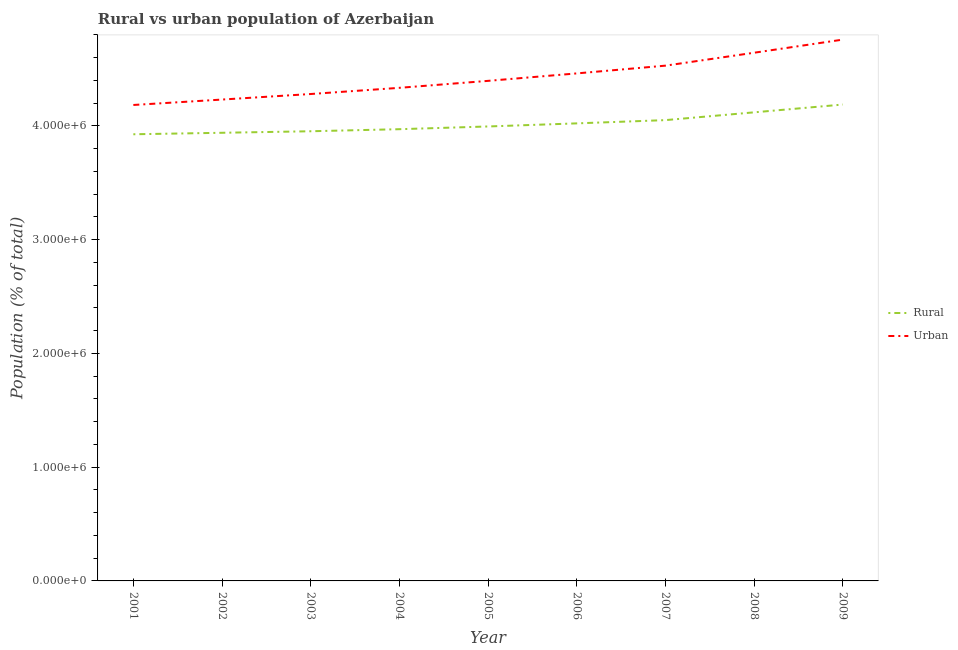How many different coloured lines are there?
Your answer should be compact. 2. What is the rural population density in 2007?
Give a very brief answer. 4.05e+06. Across all years, what is the maximum rural population density?
Your answer should be very brief. 4.19e+06. Across all years, what is the minimum urban population density?
Provide a succinct answer. 4.18e+06. What is the total urban population density in the graph?
Your response must be concise. 3.98e+07. What is the difference between the urban population density in 2002 and that in 2009?
Your answer should be very brief. -5.27e+05. What is the difference between the urban population density in 2003 and the rural population density in 2007?
Provide a succinct answer. 2.30e+05. What is the average rural population density per year?
Give a very brief answer. 4.02e+06. In the year 2004, what is the difference between the urban population density and rural population density?
Keep it short and to the point. 3.64e+05. In how many years, is the rural population density greater than 4400000 %?
Your answer should be very brief. 0. What is the ratio of the urban population density in 2008 to that in 2009?
Ensure brevity in your answer.  0.98. Is the difference between the rural population density in 2004 and 2009 greater than the difference between the urban population density in 2004 and 2009?
Provide a succinct answer. Yes. What is the difference between the highest and the second highest urban population density?
Make the answer very short. 1.15e+05. What is the difference between the highest and the lowest rural population density?
Keep it short and to the point. 2.61e+05. In how many years, is the rural population density greater than the average rural population density taken over all years?
Give a very brief answer. 4. Is the sum of the rural population density in 2001 and 2006 greater than the maximum urban population density across all years?
Your answer should be very brief. Yes. Is the urban population density strictly less than the rural population density over the years?
Your answer should be very brief. No. How many lines are there?
Offer a terse response. 2. How many years are there in the graph?
Provide a short and direct response. 9. Are the values on the major ticks of Y-axis written in scientific E-notation?
Offer a very short reply. Yes. Does the graph contain grids?
Your answer should be compact. No. How many legend labels are there?
Make the answer very short. 2. How are the legend labels stacked?
Ensure brevity in your answer.  Vertical. What is the title of the graph?
Provide a short and direct response. Rural vs urban population of Azerbaijan. What is the label or title of the X-axis?
Your answer should be very brief. Year. What is the label or title of the Y-axis?
Offer a very short reply. Population (% of total). What is the Population (% of total) in Rural in 2001?
Provide a succinct answer. 3.93e+06. What is the Population (% of total) of Urban in 2001?
Offer a terse response. 4.18e+06. What is the Population (% of total) of Rural in 2002?
Provide a succinct answer. 3.94e+06. What is the Population (% of total) in Urban in 2002?
Ensure brevity in your answer.  4.23e+06. What is the Population (% of total) of Rural in 2003?
Your answer should be compact. 3.95e+06. What is the Population (% of total) in Urban in 2003?
Make the answer very short. 4.28e+06. What is the Population (% of total) in Rural in 2004?
Your answer should be very brief. 3.97e+06. What is the Population (% of total) of Urban in 2004?
Give a very brief answer. 4.34e+06. What is the Population (% of total) in Rural in 2005?
Provide a succinct answer. 4.00e+06. What is the Population (% of total) of Urban in 2005?
Offer a very short reply. 4.40e+06. What is the Population (% of total) of Rural in 2006?
Ensure brevity in your answer.  4.02e+06. What is the Population (% of total) of Urban in 2006?
Your answer should be compact. 4.46e+06. What is the Population (% of total) in Rural in 2007?
Offer a terse response. 4.05e+06. What is the Population (% of total) of Urban in 2007?
Offer a terse response. 4.53e+06. What is the Population (% of total) in Rural in 2008?
Give a very brief answer. 4.12e+06. What is the Population (% of total) in Urban in 2008?
Ensure brevity in your answer.  4.64e+06. What is the Population (% of total) of Rural in 2009?
Your answer should be very brief. 4.19e+06. What is the Population (% of total) in Urban in 2009?
Give a very brief answer. 4.76e+06. Across all years, what is the maximum Population (% of total) of Rural?
Your answer should be compact. 4.19e+06. Across all years, what is the maximum Population (% of total) of Urban?
Provide a short and direct response. 4.76e+06. Across all years, what is the minimum Population (% of total) of Rural?
Make the answer very short. 3.93e+06. Across all years, what is the minimum Population (% of total) in Urban?
Offer a very short reply. 4.18e+06. What is the total Population (% of total) of Rural in the graph?
Provide a succinct answer. 3.62e+07. What is the total Population (% of total) of Urban in the graph?
Your answer should be compact. 3.98e+07. What is the difference between the Population (% of total) of Rural in 2001 and that in 2002?
Your answer should be very brief. -1.31e+04. What is the difference between the Population (% of total) in Urban in 2001 and that in 2002?
Your response must be concise. -4.77e+04. What is the difference between the Population (% of total) in Rural in 2001 and that in 2003?
Provide a succinct answer. -2.65e+04. What is the difference between the Population (% of total) of Urban in 2001 and that in 2003?
Your answer should be very brief. -9.64e+04. What is the difference between the Population (% of total) of Rural in 2001 and that in 2004?
Ensure brevity in your answer.  -4.45e+04. What is the difference between the Population (% of total) in Urban in 2001 and that in 2004?
Make the answer very short. -1.51e+05. What is the difference between the Population (% of total) of Rural in 2001 and that in 2005?
Ensure brevity in your answer.  -6.86e+04. What is the difference between the Population (% of total) of Urban in 2001 and that in 2005?
Your response must be concise. -2.12e+05. What is the difference between the Population (% of total) of Rural in 2001 and that in 2006?
Ensure brevity in your answer.  -9.57e+04. What is the difference between the Population (% of total) in Urban in 2001 and that in 2006?
Provide a succinct answer. -2.78e+05. What is the difference between the Population (% of total) in Rural in 2001 and that in 2007?
Your answer should be very brief. -1.24e+05. What is the difference between the Population (% of total) of Urban in 2001 and that in 2007?
Give a very brief answer. -3.46e+05. What is the difference between the Population (% of total) in Rural in 2001 and that in 2008?
Keep it short and to the point. -1.93e+05. What is the difference between the Population (% of total) of Urban in 2001 and that in 2008?
Offer a very short reply. -4.59e+05. What is the difference between the Population (% of total) of Rural in 2001 and that in 2009?
Provide a succinct answer. -2.61e+05. What is the difference between the Population (% of total) in Urban in 2001 and that in 2009?
Offer a terse response. -5.75e+05. What is the difference between the Population (% of total) of Rural in 2002 and that in 2003?
Ensure brevity in your answer.  -1.34e+04. What is the difference between the Population (% of total) of Urban in 2002 and that in 2003?
Give a very brief answer. -4.87e+04. What is the difference between the Population (% of total) in Rural in 2002 and that in 2004?
Your answer should be very brief. -3.15e+04. What is the difference between the Population (% of total) of Urban in 2002 and that in 2004?
Offer a terse response. -1.03e+05. What is the difference between the Population (% of total) of Rural in 2002 and that in 2005?
Offer a terse response. -5.55e+04. What is the difference between the Population (% of total) in Urban in 2002 and that in 2005?
Your answer should be compact. -1.64e+05. What is the difference between the Population (% of total) of Rural in 2002 and that in 2006?
Your answer should be very brief. -8.27e+04. What is the difference between the Population (% of total) in Urban in 2002 and that in 2006?
Offer a very short reply. -2.30e+05. What is the difference between the Population (% of total) in Rural in 2002 and that in 2007?
Keep it short and to the point. -1.11e+05. What is the difference between the Population (% of total) in Urban in 2002 and that in 2007?
Ensure brevity in your answer.  -2.98e+05. What is the difference between the Population (% of total) of Rural in 2002 and that in 2008?
Make the answer very short. -1.80e+05. What is the difference between the Population (% of total) in Urban in 2002 and that in 2008?
Your answer should be very brief. -4.12e+05. What is the difference between the Population (% of total) in Rural in 2002 and that in 2009?
Offer a very short reply. -2.48e+05. What is the difference between the Population (% of total) in Urban in 2002 and that in 2009?
Offer a very short reply. -5.27e+05. What is the difference between the Population (% of total) of Rural in 2003 and that in 2004?
Provide a short and direct response. -1.81e+04. What is the difference between the Population (% of total) in Urban in 2003 and that in 2004?
Offer a very short reply. -5.43e+04. What is the difference between the Population (% of total) of Rural in 2003 and that in 2005?
Give a very brief answer. -4.21e+04. What is the difference between the Population (% of total) in Urban in 2003 and that in 2005?
Provide a short and direct response. -1.16e+05. What is the difference between the Population (% of total) of Rural in 2003 and that in 2006?
Give a very brief answer. -6.93e+04. What is the difference between the Population (% of total) of Urban in 2003 and that in 2006?
Offer a very short reply. -1.81e+05. What is the difference between the Population (% of total) of Rural in 2003 and that in 2007?
Provide a short and direct response. -9.79e+04. What is the difference between the Population (% of total) in Urban in 2003 and that in 2007?
Provide a short and direct response. -2.49e+05. What is the difference between the Population (% of total) of Rural in 2003 and that in 2008?
Offer a terse response. -1.66e+05. What is the difference between the Population (% of total) of Urban in 2003 and that in 2008?
Your response must be concise. -3.63e+05. What is the difference between the Population (% of total) in Rural in 2003 and that in 2009?
Provide a short and direct response. -2.35e+05. What is the difference between the Population (% of total) in Urban in 2003 and that in 2009?
Make the answer very short. -4.78e+05. What is the difference between the Population (% of total) in Rural in 2004 and that in 2005?
Your answer should be very brief. -2.40e+04. What is the difference between the Population (% of total) of Urban in 2004 and that in 2005?
Your response must be concise. -6.13e+04. What is the difference between the Population (% of total) in Rural in 2004 and that in 2006?
Your response must be concise. -5.12e+04. What is the difference between the Population (% of total) in Urban in 2004 and that in 2006?
Your answer should be very brief. -1.27e+05. What is the difference between the Population (% of total) in Rural in 2004 and that in 2007?
Offer a very short reply. -7.98e+04. What is the difference between the Population (% of total) of Urban in 2004 and that in 2007?
Offer a terse response. -1.95e+05. What is the difference between the Population (% of total) in Rural in 2004 and that in 2008?
Offer a terse response. -1.48e+05. What is the difference between the Population (% of total) of Urban in 2004 and that in 2008?
Make the answer very short. -3.09e+05. What is the difference between the Population (% of total) of Rural in 2004 and that in 2009?
Make the answer very short. -2.17e+05. What is the difference between the Population (% of total) of Urban in 2004 and that in 2009?
Make the answer very short. -4.24e+05. What is the difference between the Population (% of total) in Rural in 2005 and that in 2006?
Ensure brevity in your answer.  -2.72e+04. What is the difference between the Population (% of total) of Urban in 2005 and that in 2006?
Provide a short and direct response. -6.55e+04. What is the difference between the Population (% of total) of Rural in 2005 and that in 2007?
Keep it short and to the point. -5.58e+04. What is the difference between the Population (% of total) of Urban in 2005 and that in 2007?
Your answer should be compact. -1.34e+05. What is the difference between the Population (% of total) in Rural in 2005 and that in 2008?
Keep it short and to the point. -1.24e+05. What is the difference between the Population (% of total) in Urban in 2005 and that in 2008?
Your answer should be very brief. -2.47e+05. What is the difference between the Population (% of total) in Rural in 2005 and that in 2009?
Offer a terse response. -1.93e+05. What is the difference between the Population (% of total) in Urban in 2005 and that in 2009?
Your answer should be compact. -3.63e+05. What is the difference between the Population (% of total) of Rural in 2006 and that in 2007?
Provide a short and direct response. -2.86e+04. What is the difference between the Population (% of total) of Urban in 2006 and that in 2007?
Offer a terse response. -6.81e+04. What is the difference between the Population (% of total) in Rural in 2006 and that in 2008?
Offer a terse response. -9.71e+04. What is the difference between the Population (% of total) in Urban in 2006 and that in 2008?
Give a very brief answer. -1.82e+05. What is the difference between the Population (% of total) in Rural in 2006 and that in 2009?
Your answer should be very brief. -1.66e+05. What is the difference between the Population (% of total) of Urban in 2006 and that in 2009?
Ensure brevity in your answer.  -2.97e+05. What is the difference between the Population (% of total) in Rural in 2007 and that in 2008?
Your response must be concise. -6.84e+04. What is the difference between the Population (% of total) of Urban in 2007 and that in 2008?
Offer a terse response. -1.14e+05. What is the difference between the Population (% of total) of Rural in 2007 and that in 2009?
Your answer should be compact. -1.37e+05. What is the difference between the Population (% of total) of Urban in 2007 and that in 2009?
Your response must be concise. -2.29e+05. What is the difference between the Population (% of total) in Rural in 2008 and that in 2009?
Your answer should be compact. -6.85e+04. What is the difference between the Population (% of total) of Urban in 2008 and that in 2009?
Offer a terse response. -1.15e+05. What is the difference between the Population (% of total) of Rural in 2001 and the Population (% of total) of Urban in 2002?
Keep it short and to the point. -3.05e+05. What is the difference between the Population (% of total) in Rural in 2001 and the Population (% of total) in Urban in 2003?
Offer a very short reply. -3.54e+05. What is the difference between the Population (% of total) of Rural in 2001 and the Population (% of total) of Urban in 2004?
Provide a short and direct response. -4.08e+05. What is the difference between the Population (% of total) in Rural in 2001 and the Population (% of total) in Urban in 2005?
Your answer should be very brief. -4.70e+05. What is the difference between the Population (% of total) of Rural in 2001 and the Population (% of total) of Urban in 2006?
Offer a terse response. -5.35e+05. What is the difference between the Population (% of total) in Rural in 2001 and the Population (% of total) in Urban in 2007?
Ensure brevity in your answer.  -6.03e+05. What is the difference between the Population (% of total) of Rural in 2001 and the Population (% of total) of Urban in 2008?
Your answer should be very brief. -7.17e+05. What is the difference between the Population (% of total) in Rural in 2001 and the Population (% of total) in Urban in 2009?
Offer a terse response. -8.32e+05. What is the difference between the Population (% of total) in Rural in 2002 and the Population (% of total) in Urban in 2003?
Offer a terse response. -3.41e+05. What is the difference between the Population (% of total) in Rural in 2002 and the Population (% of total) in Urban in 2004?
Your answer should be very brief. -3.95e+05. What is the difference between the Population (% of total) of Rural in 2002 and the Population (% of total) of Urban in 2005?
Your answer should be very brief. -4.56e+05. What is the difference between the Population (% of total) of Rural in 2002 and the Population (% of total) of Urban in 2006?
Offer a terse response. -5.22e+05. What is the difference between the Population (% of total) in Rural in 2002 and the Population (% of total) in Urban in 2007?
Ensure brevity in your answer.  -5.90e+05. What is the difference between the Population (% of total) in Rural in 2002 and the Population (% of total) in Urban in 2008?
Your answer should be compact. -7.04e+05. What is the difference between the Population (% of total) of Rural in 2002 and the Population (% of total) of Urban in 2009?
Make the answer very short. -8.19e+05. What is the difference between the Population (% of total) in Rural in 2003 and the Population (% of total) in Urban in 2004?
Offer a terse response. -3.82e+05. What is the difference between the Population (% of total) of Rural in 2003 and the Population (% of total) of Urban in 2005?
Make the answer very short. -4.43e+05. What is the difference between the Population (% of total) of Rural in 2003 and the Population (% of total) of Urban in 2006?
Ensure brevity in your answer.  -5.09e+05. What is the difference between the Population (% of total) of Rural in 2003 and the Population (% of total) of Urban in 2007?
Ensure brevity in your answer.  -5.77e+05. What is the difference between the Population (% of total) of Rural in 2003 and the Population (% of total) of Urban in 2008?
Make the answer very short. -6.90e+05. What is the difference between the Population (% of total) in Rural in 2003 and the Population (% of total) in Urban in 2009?
Your response must be concise. -8.06e+05. What is the difference between the Population (% of total) in Rural in 2004 and the Population (% of total) in Urban in 2005?
Offer a very short reply. -4.25e+05. What is the difference between the Population (% of total) in Rural in 2004 and the Population (% of total) in Urban in 2006?
Your answer should be compact. -4.91e+05. What is the difference between the Population (% of total) in Rural in 2004 and the Population (% of total) in Urban in 2007?
Your response must be concise. -5.59e+05. What is the difference between the Population (% of total) in Rural in 2004 and the Population (% of total) in Urban in 2008?
Ensure brevity in your answer.  -6.72e+05. What is the difference between the Population (% of total) of Rural in 2004 and the Population (% of total) of Urban in 2009?
Offer a very short reply. -7.88e+05. What is the difference between the Population (% of total) of Rural in 2005 and the Population (% of total) of Urban in 2006?
Your answer should be compact. -4.66e+05. What is the difference between the Population (% of total) of Rural in 2005 and the Population (% of total) of Urban in 2007?
Your answer should be compact. -5.35e+05. What is the difference between the Population (% of total) in Rural in 2005 and the Population (% of total) in Urban in 2008?
Provide a short and direct response. -6.48e+05. What is the difference between the Population (% of total) of Rural in 2005 and the Population (% of total) of Urban in 2009?
Provide a succinct answer. -7.64e+05. What is the difference between the Population (% of total) in Rural in 2006 and the Population (% of total) in Urban in 2007?
Offer a terse response. -5.07e+05. What is the difference between the Population (% of total) in Rural in 2006 and the Population (% of total) in Urban in 2008?
Provide a succinct answer. -6.21e+05. What is the difference between the Population (% of total) of Rural in 2006 and the Population (% of total) of Urban in 2009?
Ensure brevity in your answer.  -7.36e+05. What is the difference between the Population (% of total) of Rural in 2007 and the Population (% of total) of Urban in 2008?
Provide a succinct answer. -5.92e+05. What is the difference between the Population (% of total) in Rural in 2007 and the Population (% of total) in Urban in 2009?
Your response must be concise. -7.08e+05. What is the difference between the Population (% of total) of Rural in 2008 and the Population (% of total) of Urban in 2009?
Ensure brevity in your answer.  -6.39e+05. What is the average Population (% of total) of Rural per year?
Make the answer very short. 4.02e+06. What is the average Population (% of total) in Urban per year?
Give a very brief answer. 4.42e+06. In the year 2001, what is the difference between the Population (% of total) in Rural and Population (% of total) in Urban?
Make the answer very short. -2.57e+05. In the year 2002, what is the difference between the Population (% of total) in Rural and Population (% of total) in Urban?
Give a very brief answer. -2.92e+05. In the year 2003, what is the difference between the Population (% of total) in Rural and Population (% of total) in Urban?
Offer a terse response. -3.27e+05. In the year 2004, what is the difference between the Population (% of total) of Rural and Population (% of total) of Urban?
Provide a succinct answer. -3.64e+05. In the year 2005, what is the difference between the Population (% of total) of Rural and Population (% of total) of Urban?
Your answer should be very brief. -4.01e+05. In the year 2006, what is the difference between the Population (% of total) of Rural and Population (% of total) of Urban?
Your answer should be very brief. -4.39e+05. In the year 2007, what is the difference between the Population (% of total) of Rural and Population (% of total) of Urban?
Offer a terse response. -4.79e+05. In the year 2008, what is the difference between the Population (% of total) in Rural and Population (% of total) in Urban?
Make the answer very short. -5.24e+05. In the year 2009, what is the difference between the Population (% of total) of Rural and Population (% of total) of Urban?
Keep it short and to the point. -5.71e+05. What is the ratio of the Population (% of total) in Rural in 2001 to that in 2002?
Make the answer very short. 1. What is the ratio of the Population (% of total) in Urban in 2001 to that in 2002?
Give a very brief answer. 0.99. What is the ratio of the Population (% of total) of Urban in 2001 to that in 2003?
Offer a very short reply. 0.98. What is the ratio of the Population (% of total) of Rural in 2001 to that in 2004?
Give a very brief answer. 0.99. What is the ratio of the Population (% of total) in Urban in 2001 to that in 2004?
Offer a very short reply. 0.97. What is the ratio of the Population (% of total) in Rural in 2001 to that in 2005?
Your answer should be very brief. 0.98. What is the ratio of the Population (% of total) of Urban in 2001 to that in 2005?
Make the answer very short. 0.95. What is the ratio of the Population (% of total) in Rural in 2001 to that in 2006?
Provide a short and direct response. 0.98. What is the ratio of the Population (% of total) of Urban in 2001 to that in 2006?
Offer a terse response. 0.94. What is the ratio of the Population (% of total) in Rural in 2001 to that in 2007?
Ensure brevity in your answer.  0.97. What is the ratio of the Population (% of total) of Urban in 2001 to that in 2007?
Your answer should be compact. 0.92. What is the ratio of the Population (% of total) of Rural in 2001 to that in 2008?
Give a very brief answer. 0.95. What is the ratio of the Population (% of total) of Urban in 2001 to that in 2008?
Offer a terse response. 0.9. What is the ratio of the Population (% of total) in Rural in 2001 to that in 2009?
Give a very brief answer. 0.94. What is the ratio of the Population (% of total) in Urban in 2001 to that in 2009?
Provide a succinct answer. 0.88. What is the ratio of the Population (% of total) in Rural in 2002 to that in 2003?
Keep it short and to the point. 1. What is the ratio of the Population (% of total) of Urban in 2002 to that in 2004?
Provide a short and direct response. 0.98. What is the ratio of the Population (% of total) in Rural in 2002 to that in 2005?
Offer a very short reply. 0.99. What is the ratio of the Population (% of total) in Urban in 2002 to that in 2005?
Provide a short and direct response. 0.96. What is the ratio of the Population (% of total) of Rural in 2002 to that in 2006?
Your answer should be compact. 0.98. What is the ratio of the Population (% of total) in Urban in 2002 to that in 2006?
Your response must be concise. 0.95. What is the ratio of the Population (% of total) in Rural in 2002 to that in 2007?
Give a very brief answer. 0.97. What is the ratio of the Population (% of total) of Urban in 2002 to that in 2007?
Make the answer very short. 0.93. What is the ratio of the Population (% of total) in Rural in 2002 to that in 2008?
Your answer should be very brief. 0.96. What is the ratio of the Population (% of total) in Urban in 2002 to that in 2008?
Your response must be concise. 0.91. What is the ratio of the Population (% of total) of Rural in 2002 to that in 2009?
Your response must be concise. 0.94. What is the ratio of the Population (% of total) in Urban in 2002 to that in 2009?
Keep it short and to the point. 0.89. What is the ratio of the Population (% of total) of Rural in 2003 to that in 2004?
Keep it short and to the point. 1. What is the ratio of the Population (% of total) in Urban in 2003 to that in 2004?
Offer a very short reply. 0.99. What is the ratio of the Population (% of total) of Urban in 2003 to that in 2005?
Make the answer very short. 0.97. What is the ratio of the Population (% of total) in Rural in 2003 to that in 2006?
Offer a terse response. 0.98. What is the ratio of the Population (% of total) of Urban in 2003 to that in 2006?
Ensure brevity in your answer.  0.96. What is the ratio of the Population (% of total) of Rural in 2003 to that in 2007?
Your answer should be very brief. 0.98. What is the ratio of the Population (% of total) in Urban in 2003 to that in 2007?
Offer a terse response. 0.94. What is the ratio of the Population (% of total) in Rural in 2003 to that in 2008?
Offer a terse response. 0.96. What is the ratio of the Population (% of total) of Urban in 2003 to that in 2008?
Ensure brevity in your answer.  0.92. What is the ratio of the Population (% of total) in Rural in 2003 to that in 2009?
Provide a succinct answer. 0.94. What is the ratio of the Population (% of total) of Urban in 2003 to that in 2009?
Your answer should be compact. 0.9. What is the ratio of the Population (% of total) of Rural in 2004 to that in 2005?
Provide a succinct answer. 0.99. What is the ratio of the Population (% of total) in Urban in 2004 to that in 2005?
Keep it short and to the point. 0.99. What is the ratio of the Population (% of total) in Rural in 2004 to that in 2006?
Provide a short and direct response. 0.99. What is the ratio of the Population (% of total) of Urban in 2004 to that in 2006?
Provide a short and direct response. 0.97. What is the ratio of the Population (% of total) of Rural in 2004 to that in 2007?
Provide a succinct answer. 0.98. What is the ratio of the Population (% of total) in Urban in 2004 to that in 2007?
Your answer should be compact. 0.96. What is the ratio of the Population (% of total) of Rural in 2004 to that in 2008?
Give a very brief answer. 0.96. What is the ratio of the Population (% of total) in Urban in 2004 to that in 2008?
Provide a short and direct response. 0.93. What is the ratio of the Population (% of total) in Rural in 2004 to that in 2009?
Your response must be concise. 0.95. What is the ratio of the Population (% of total) in Urban in 2004 to that in 2009?
Provide a short and direct response. 0.91. What is the ratio of the Population (% of total) of Rural in 2005 to that in 2007?
Give a very brief answer. 0.99. What is the ratio of the Population (% of total) in Urban in 2005 to that in 2007?
Offer a very short reply. 0.97. What is the ratio of the Population (% of total) in Rural in 2005 to that in 2008?
Give a very brief answer. 0.97. What is the ratio of the Population (% of total) of Urban in 2005 to that in 2008?
Make the answer very short. 0.95. What is the ratio of the Population (% of total) of Rural in 2005 to that in 2009?
Offer a very short reply. 0.95. What is the ratio of the Population (% of total) in Urban in 2005 to that in 2009?
Your answer should be very brief. 0.92. What is the ratio of the Population (% of total) of Urban in 2006 to that in 2007?
Your response must be concise. 0.98. What is the ratio of the Population (% of total) in Rural in 2006 to that in 2008?
Your answer should be very brief. 0.98. What is the ratio of the Population (% of total) of Urban in 2006 to that in 2008?
Provide a succinct answer. 0.96. What is the ratio of the Population (% of total) of Rural in 2006 to that in 2009?
Your response must be concise. 0.96. What is the ratio of the Population (% of total) of Urban in 2006 to that in 2009?
Offer a very short reply. 0.94. What is the ratio of the Population (% of total) of Rural in 2007 to that in 2008?
Provide a succinct answer. 0.98. What is the ratio of the Population (% of total) in Urban in 2007 to that in 2008?
Your answer should be very brief. 0.98. What is the ratio of the Population (% of total) of Rural in 2007 to that in 2009?
Provide a short and direct response. 0.97. What is the ratio of the Population (% of total) in Urban in 2007 to that in 2009?
Offer a terse response. 0.95. What is the ratio of the Population (% of total) of Rural in 2008 to that in 2009?
Your response must be concise. 0.98. What is the ratio of the Population (% of total) in Urban in 2008 to that in 2009?
Offer a terse response. 0.98. What is the difference between the highest and the second highest Population (% of total) of Rural?
Your answer should be compact. 6.85e+04. What is the difference between the highest and the second highest Population (% of total) in Urban?
Make the answer very short. 1.15e+05. What is the difference between the highest and the lowest Population (% of total) of Rural?
Offer a very short reply. 2.61e+05. What is the difference between the highest and the lowest Population (% of total) of Urban?
Your response must be concise. 5.75e+05. 